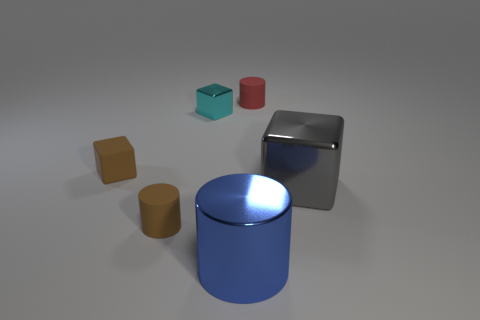What is the material of the cylinder right of the metal cylinder?
Your answer should be very brief. Rubber. Is the material of the small cylinder in front of the small shiny object the same as the brown block?
Offer a very short reply. Yes. The large thing that is to the left of the tiny cylinder that is behind the small cylinder that is on the left side of the tiny cyan block is what shape?
Provide a succinct answer. Cylinder. Are there any metallic cubes of the same size as the blue metallic object?
Keep it short and to the point. Yes. How big is the shiny cylinder?
Your response must be concise. Large. How many red matte cylinders are the same size as the cyan shiny block?
Give a very brief answer. 1. Is the number of shiny blocks in front of the tiny brown rubber block less than the number of metallic things that are to the left of the gray metal object?
Your response must be concise. Yes. There is a brown matte cube that is left of the rubber object that is on the right side of the large object on the left side of the tiny red matte cylinder; how big is it?
Ensure brevity in your answer.  Small. There is a matte object that is both behind the brown cylinder and in front of the cyan cube; what size is it?
Make the answer very short. Small. There is a tiny brown rubber thing that is on the left side of the small brown object right of the small rubber block; what is its shape?
Provide a succinct answer. Cube. 